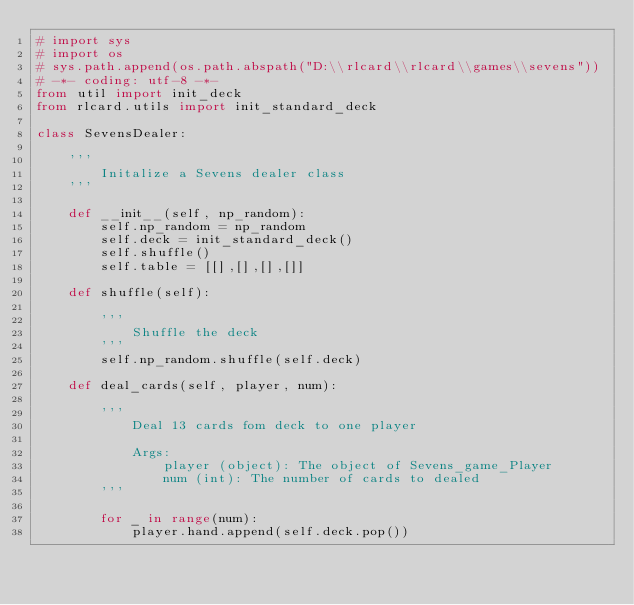<code> <loc_0><loc_0><loc_500><loc_500><_Python_># import sys
# import os
# sys.path.append(os.path.abspath("D:\\rlcard\\rlcard\\games\\sevens"))
# -*- coding: utf-8 -*-
from util import init_deck
from rlcard.utils import init_standard_deck

class SevensDealer:
    
    '''
        Initalize a Sevens dealer class
    '''

    def __init__(self, np_random):
        self.np_random = np_random
        self.deck = init_standard_deck()
        self.shuffle()
        self.table = [[],[],[],[]]
    
    def shuffle(self):

        '''
            Shuffle the deck
        '''
        self.np_random.shuffle(self.deck)
    
    def deal_cards(self, player, num):

        '''
            Deal 13 cards fom deck to one player

            Args:
                player (object): The object of Sevens_game_Player
                num (int): The number of cards to dealed
        '''

        for _ in range(num):
            player.hand.append(self.deck.pop())
</code> 